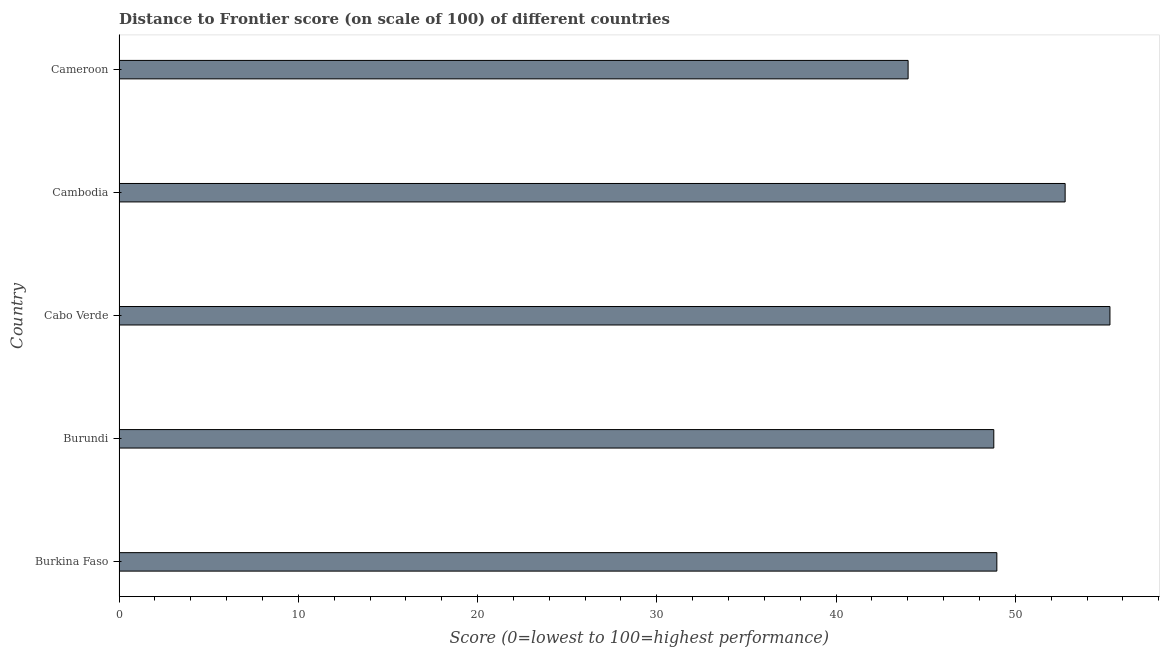Does the graph contain any zero values?
Give a very brief answer. No. Does the graph contain grids?
Provide a succinct answer. No. What is the title of the graph?
Your answer should be compact. Distance to Frontier score (on scale of 100) of different countries. What is the label or title of the X-axis?
Your answer should be very brief. Score (0=lowest to 100=highest performance). What is the label or title of the Y-axis?
Offer a terse response. Country. What is the distance to frontier score in Cabo Verde?
Provide a succinct answer. 55.28. Across all countries, what is the maximum distance to frontier score?
Make the answer very short. 55.28. Across all countries, what is the minimum distance to frontier score?
Make the answer very short. 44.02. In which country was the distance to frontier score maximum?
Your response must be concise. Cabo Verde. In which country was the distance to frontier score minimum?
Offer a terse response. Cameroon. What is the sum of the distance to frontier score?
Your answer should be very brief. 249.85. What is the difference between the distance to frontier score in Burundi and Cameroon?
Offer a very short reply. 4.78. What is the average distance to frontier score per country?
Your response must be concise. 49.97. What is the median distance to frontier score?
Your response must be concise. 48.97. In how many countries, is the distance to frontier score greater than 30 ?
Your answer should be very brief. 5. What is the ratio of the distance to frontier score in Cabo Verde to that in Cambodia?
Give a very brief answer. 1.05. Is the sum of the distance to frontier score in Cabo Verde and Cambodia greater than the maximum distance to frontier score across all countries?
Offer a terse response. Yes. What is the difference between the highest and the lowest distance to frontier score?
Make the answer very short. 11.26. In how many countries, is the distance to frontier score greater than the average distance to frontier score taken over all countries?
Your answer should be compact. 2. Are all the bars in the graph horizontal?
Offer a terse response. Yes. Are the values on the major ticks of X-axis written in scientific E-notation?
Your response must be concise. No. What is the Score (0=lowest to 100=highest performance) of Burkina Faso?
Provide a short and direct response. 48.97. What is the Score (0=lowest to 100=highest performance) in Burundi?
Provide a succinct answer. 48.8. What is the Score (0=lowest to 100=highest performance) of Cabo Verde?
Your answer should be very brief. 55.28. What is the Score (0=lowest to 100=highest performance) of Cambodia?
Offer a very short reply. 52.78. What is the Score (0=lowest to 100=highest performance) in Cameroon?
Offer a very short reply. 44.02. What is the difference between the Score (0=lowest to 100=highest performance) in Burkina Faso and Burundi?
Give a very brief answer. 0.17. What is the difference between the Score (0=lowest to 100=highest performance) in Burkina Faso and Cabo Verde?
Your answer should be very brief. -6.31. What is the difference between the Score (0=lowest to 100=highest performance) in Burkina Faso and Cambodia?
Provide a succinct answer. -3.81. What is the difference between the Score (0=lowest to 100=highest performance) in Burkina Faso and Cameroon?
Offer a very short reply. 4.95. What is the difference between the Score (0=lowest to 100=highest performance) in Burundi and Cabo Verde?
Your answer should be compact. -6.48. What is the difference between the Score (0=lowest to 100=highest performance) in Burundi and Cambodia?
Make the answer very short. -3.98. What is the difference between the Score (0=lowest to 100=highest performance) in Burundi and Cameroon?
Provide a succinct answer. 4.78. What is the difference between the Score (0=lowest to 100=highest performance) in Cabo Verde and Cambodia?
Offer a terse response. 2.5. What is the difference between the Score (0=lowest to 100=highest performance) in Cabo Verde and Cameroon?
Offer a very short reply. 11.26. What is the difference between the Score (0=lowest to 100=highest performance) in Cambodia and Cameroon?
Make the answer very short. 8.76. What is the ratio of the Score (0=lowest to 100=highest performance) in Burkina Faso to that in Burundi?
Offer a very short reply. 1. What is the ratio of the Score (0=lowest to 100=highest performance) in Burkina Faso to that in Cabo Verde?
Your response must be concise. 0.89. What is the ratio of the Score (0=lowest to 100=highest performance) in Burkina Faso to that in Cambodia?
Keep it short and to the point. 0.93. What is the ratio of the Score (0=lowest to 100=highest performance) in Burkina Faso to that in Cameroon?
Provide a succinct answer. 1.11. What is the ratio of the Score (0=lowest to 100=highest performance) in Burundi to that in Cabo Verde?
Your response must be concise. 0.88. What is the ratio of the Score (0=lowest to 100=highest performance) in Burundi to that in Cambodia?
Give a very brief answer. 0.93. What is the ratio of the Score (0=lowest to 100=highest performance) in Burundi to that in Cameroon?
Provide a short and direct response. 1.11. What is the ratio of the Score (0=lowest to 100=highest performance) in Cabo Verde to that in Cambodia?
Your response must be concise. 1.05. What is the ratio of the Score (0=lowest to 100=highest performance) in Cabo Verde to that in Cameroon?
Give a very brief answer. 1.26. What is the ratio of the Score (0=lowest to 100=highest performance) in Cambodia to that in Cameroon?
Your answer should be compact. 1.2. 